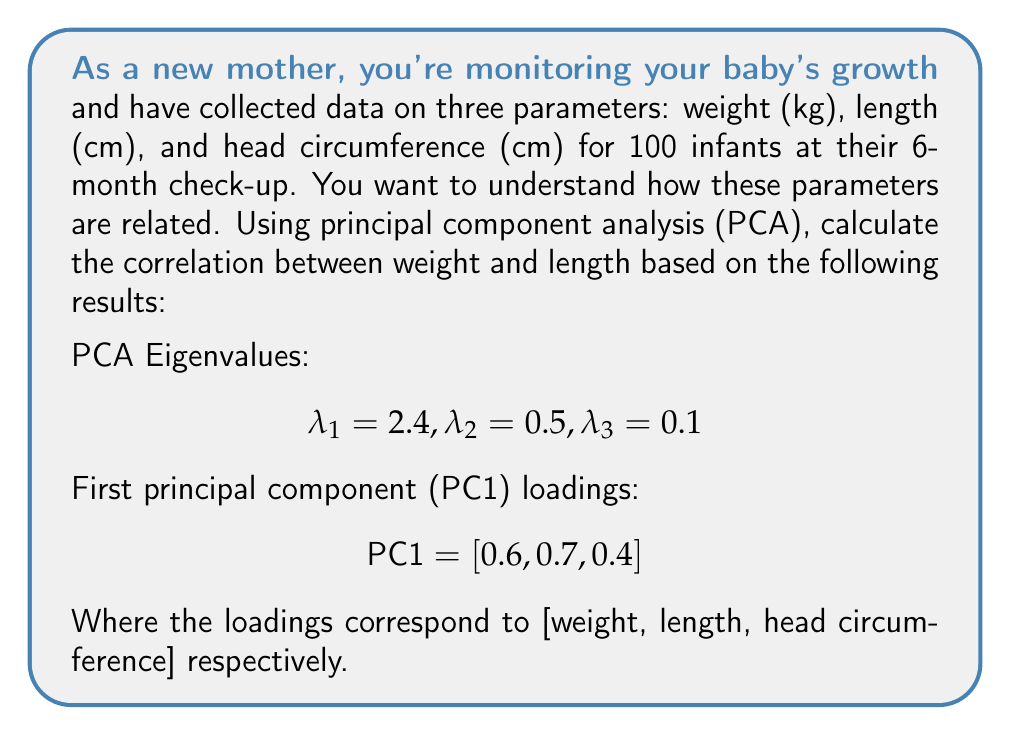Provide a solution to this math problem. To calculate the correlation between weight and length using PCA results, we'll follow these steps:

1) In PCA, the correlation between two variables can be approximated using the loadings of the first principal component (PC1) and the proportion of variance explained by PC1.

2) The proportion of variance explained by PC1 is:

   $$\frac{\lambda_1}{\lambda_1 + \lambda_2 + \lambda_3} = \frac{2.4}{2.4 + 0.5 + 0.1} = \frac{2.4}{3} = 0.8$$

3) The correlation between weight (variable i) and length (variable j) can be approximated as:

   $$r_{ij} \approx l_i \cdot l_j \cdot \sqrt{\text{proportion of variance explained by PC1}}$$

   Where $l_i$ and $l_j$ are the loadings of variables i and j on PC1.

4) For weight and length:
   $l_{\text{weight}} = 0.6$
   $l_{\text{length}} = 0.7$

5) Plugging these values into the formula:

   $$r_{\text{weight,length}} \approx 0.6 \cdot 0.7 \cdot \sqrt{0.8} = 0.6 \cdot 0.7 \cdot 0.894 = 0.376$$

Therefore, the approximate correlation between weight and length is 0.376.
Answer: $r_{\text{weight,length}} \approx 0.376$ 